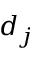<formula> <loc_0><loc_0><loc_500><loc_500>d _ { j }</formula> 